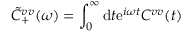Convert formula to latex. <formula><loc_0><loc_0><loc_500><loc_500>\tilde { C } _ { + } ^ { v v } ( \omega ) = \int _ { 0 } ^ { \infty } d t e ^ { i \omega t } C ^ { v v } ( t )</formula> 